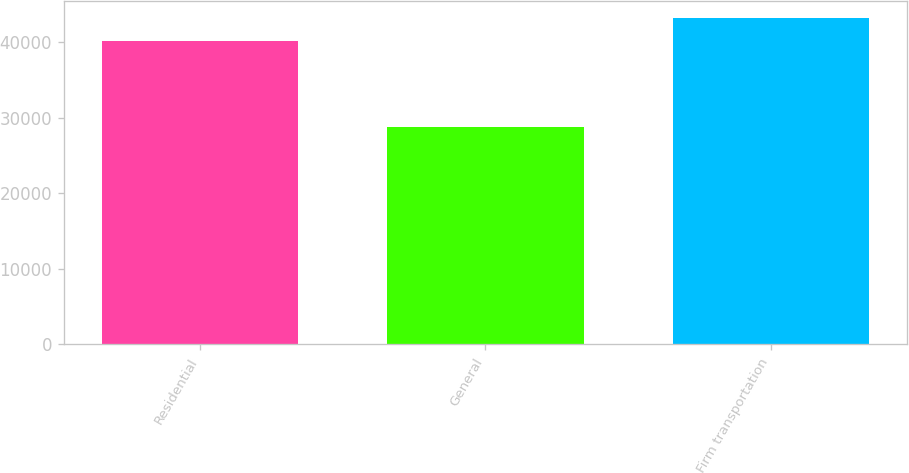<chart> <loc_0><loc_0><loc_500><loc_500><bar_chart><fcel>Residential<fcel>General<fcel>Firm transportation<nl><fcel>40195<fcel>28748<fcel>43245<nl></chart> 